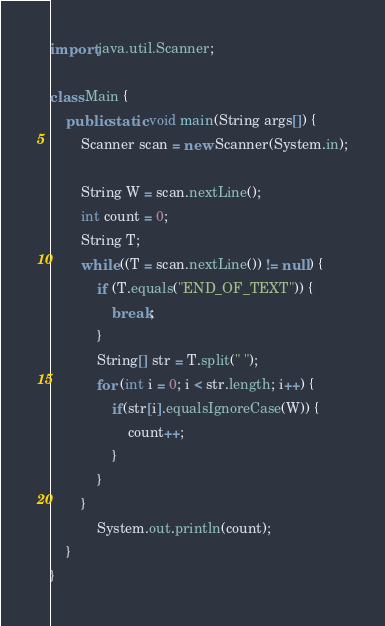<code> <loc_0><loc_0><loc_500><loc_500><_Java_>import java.util.Scanner;

class Main {
    public static void main(String args[]) {
        Scanner scan = new Scanner(System.in);

        String W = scan.nextLine();
        int count = 0;
        String T;
        while ((T = scan.nextLine()) != null) {
            if (T.equals("END_OF_TEXT")) {
                break;
            }
            String[] str = T.split(" ");
            for (int i = 0; i < str.length; i++) {
                if(str[i].equalsIgnoreCase(W)) {
                    count++;
                }
            }
        }
            System.out.println(count);
    }
}</code> 